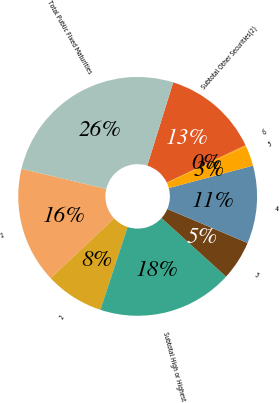<chart> <loc_0><loc_0><loc_500><loc_500><pie_chart><fcel>1<fcel>2<fcel>Subtotal High or Highest<fcel>3<fcel>4<fcel>5<fcel>6<fcel>Subtotal Other Securities(2)<fcel>Total Public Fixed Maturities<nl><fcel>15.72%<fcel>7.94%<fcel>18.32%<fcel>5.35%<fcel>10.53%<fcel>2.75%<fcel>0.16%<fcel>13.13%<fcel>26.1%<nl></chart> 